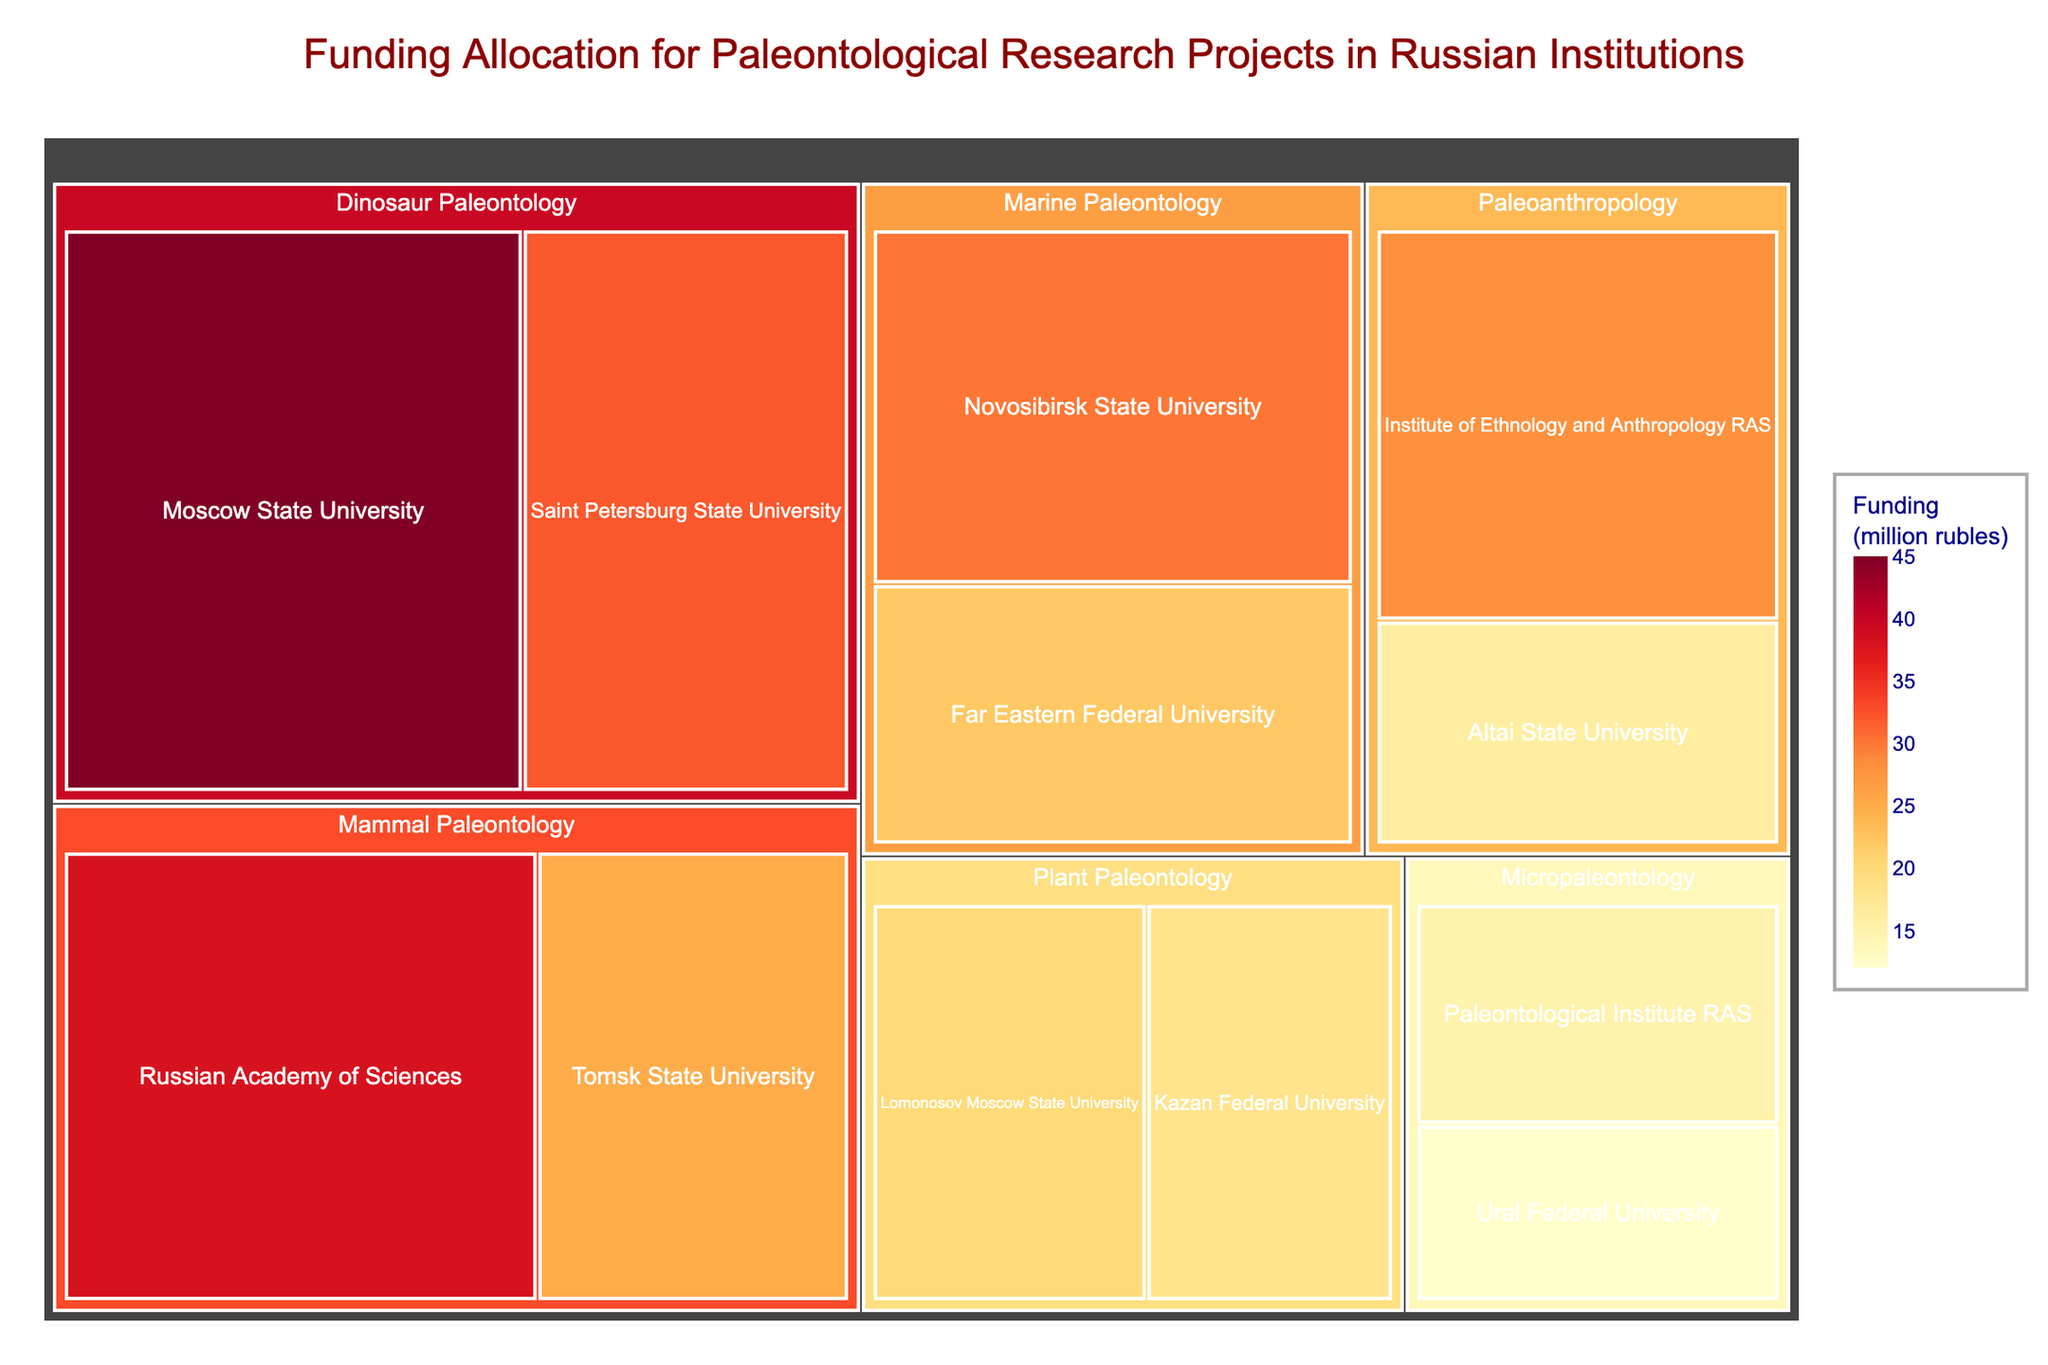Which institution received the most funding for Dinosaur Paleontology? Look at the segment under "Dinosaur Paleontology" and compare funding amounts for each institution grouped there.
Answer: Moscow State University What is the total funding allocated for Marine Paleontology? Sum the funding amounts for Novosibirsk State University and Far Eastern Federal University within "Marine Paleontology". 30 + 22 = 52 million rubles
Answer: 52 million rubles Which research area received the highest allocation of funding overall? Identify the research area with the largest combined block size in the treemap.
Answer: Dinosaur Paleontology How much more funding did Moscow State University receive compared to Altai State University? Subtract Altai State University's funding from Moscow State University's. 45 - 16 = 29 million rubles
Answer: 29 million rubles Which institution within Paleoanthropology had the lower funding? Compare funding amounts for institutions under "Paleoanthropology". Altai State University has less compared to Institute of Ethnology and Anthropology RAS.
Answer: Altai State University What is the combined funding for all research areas related to 'Plant Paleontology'? Sum the funding amounts for Lomonosov Moscow State University and Kazan Federal University under "Plant Paleontology". 20 + 18 = 38 million rubles
Answer: 38 million rubles Does the Ural Federal University have the lowest funding allocation among all institutions? Compare Ural Federal University's funding with all other institutions' funding amounts. Ural Federal University received 12 million rubles, less than any other institution listed.
Answer: Yes Which research area received more funding: Micropaleontology or Paleoanthropology? Compare the total funding sums of both areas. Micropaleontology: 15 + 12 = 27 million rubles. Paleoanthropology: 28 + 16 = 44 million rubles.
Answer: Paleoanthropology 